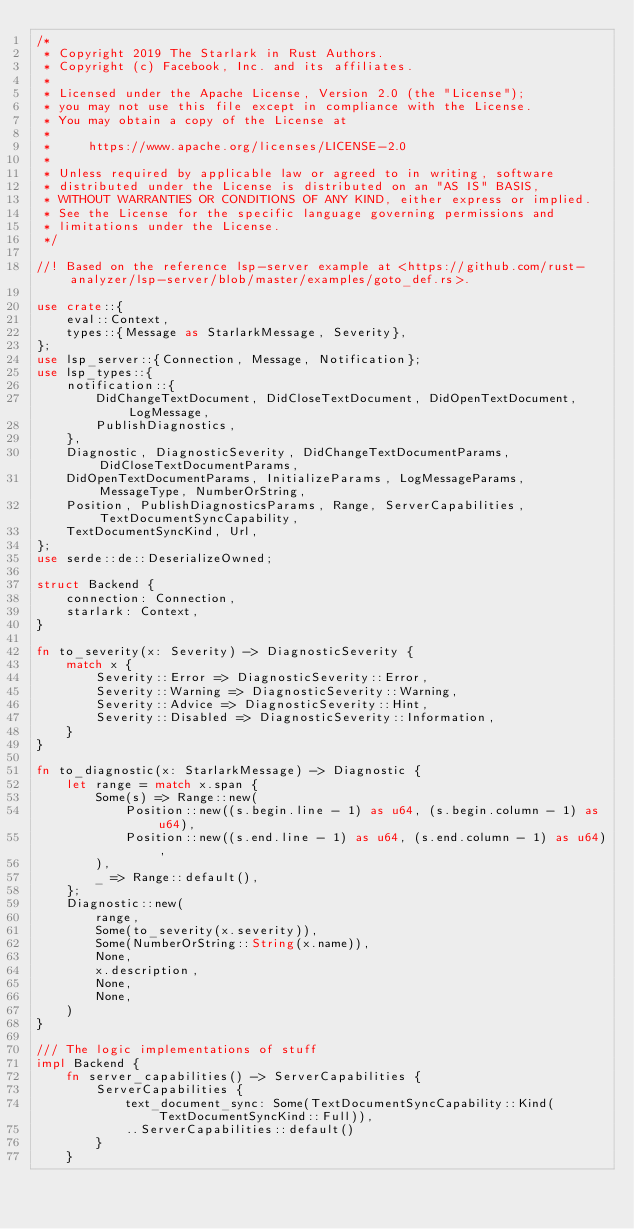<code> <loc_0><loc_0><loc_500><loc_500><_Rust_>/*
 * Copyright 2019 The Starlark in Rust Authors.
 * Copyright (c) Facebook, Inc. and its affiliates.
 *
 * Licensed under the Apache License, Version 2.0 (the "License");
 * you may not use this file except in compliance with the License.
 * You may obtain a copy of the License at
 *
 *     https://www.apache.org/licenses/LICENSE-2.0
 *
 * Unless required by applicable law or agreed to in writing, software
 * distributed under the License is distributed on an "AS IS" BASIS,
 * WITHOUT WARRANTIES OR CONDITIONS OF ANY KIND, either express or implied.
 * See the License for the specific language governing permissions and
 * limitations under the License.
 */

//! Based on the reference lsp-server example at <https://github.com/rust-analyzer/lsp-server/blob/master/examples/goto_def.rs>.

use crate::{
    eval::Context,
    types::{Message as StarlarkMessage, Severity},
};
use lsp_server::{Connection, Message, Notification};
use lsp_types::{
    notification::{
        DidChangeTextDocument, DidCloseTextDocument, DidOpenTextDocument, LogMessage,
        PublishDiagnostics,
    },
    Diagnostic, DiagnosticSeverity, DidChangeTextDocumentParams, DidCloseTextDocumentParams,
    DidOpenTextDocumentParams, InitializeParams, LogMessageParams, MessageType, NumberOrString,
    Position, PublishDiagnosticsParams, Range, ServerCapabilities, TextDocumentSyncCapability,
    TextDocumentSyncKind, Url,
};
use serde::de::DeserializeOwned;

struct Backend {
    connection: Connection,
    starlark: Context,
}

fn to_severity(x: Severity) -> DiagnosticSeverity {
    match x {
        Severity::Error => DiagnosticSeverity::Error,
        Severity::Warning => DiagnosticSeverity::Warning,
        Severity::Advice => DiagnosticSeverity::Hint,
        Severity::Disabled => DiagnosticSeverity::Information,
    }
}

fn to_diagnostic(x: StarlarkMessage) -> Diagnostic {
    let range = match x.span {
        Some(s) => Range::new(
            Position::new((s.begin.line - 1) as u64, (s.begin.column - 1) as u64),
            Position::new((s.end.line - 1) as u64, (s.end.column - 1) as u64),
        ),
        _ => Range::default(),
    };
    Diagnostic::new(
        range,
        Some(to_severity(x.severity)),
        Some(NumberOrString::String(x.name)),
        None,
        x.description,
        None,
        None,
    )
}

/// The logic implementations of stuff
impl Backend {
    fn server_capabilities() -> ServerCapabilities {
        ServerCapabilities {
            text_document_sync: Some(TextDocumentSyncCapability::Kind(TextDocumentSyncKind::Full)),
            ..ServerCapabilities::default()
        }
    }
</code> 